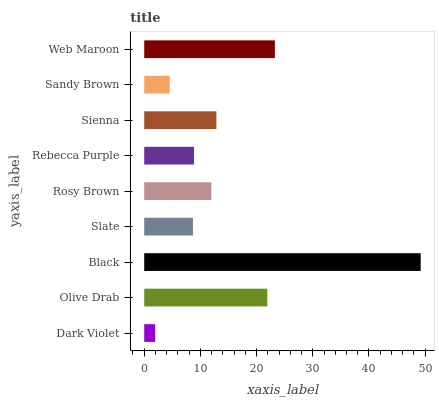Is Dark Violet the minimum?
Answer yes or no. Yes. Is Black the maximum?
Answer yes or no. Yes. Is Olive Drab the minimum?
Answer yes or no. No. Is Olive Drab the maximum?
Answer yes or no. No. Is Olive Drab greater than Dark Violet?
Answer yes or no. Yes. Is Dark Violet less than Olive Drab?
Answer yes or no. Yes. Is Dark Violet greater than Olive Drab?
Answer yes or no. No. Is Olive Drab less than Dark Violet?
Answer yes or no. No. Is Rosy Brown the high median?
Answer yes or no. Yes. Is Rosy Brown the low median?
Answer yes or no. Yes. Is Web Maroon the high median?
Answer yes or no. No. Is Rebecca Purple the low median?
Answer yes or no. No. 